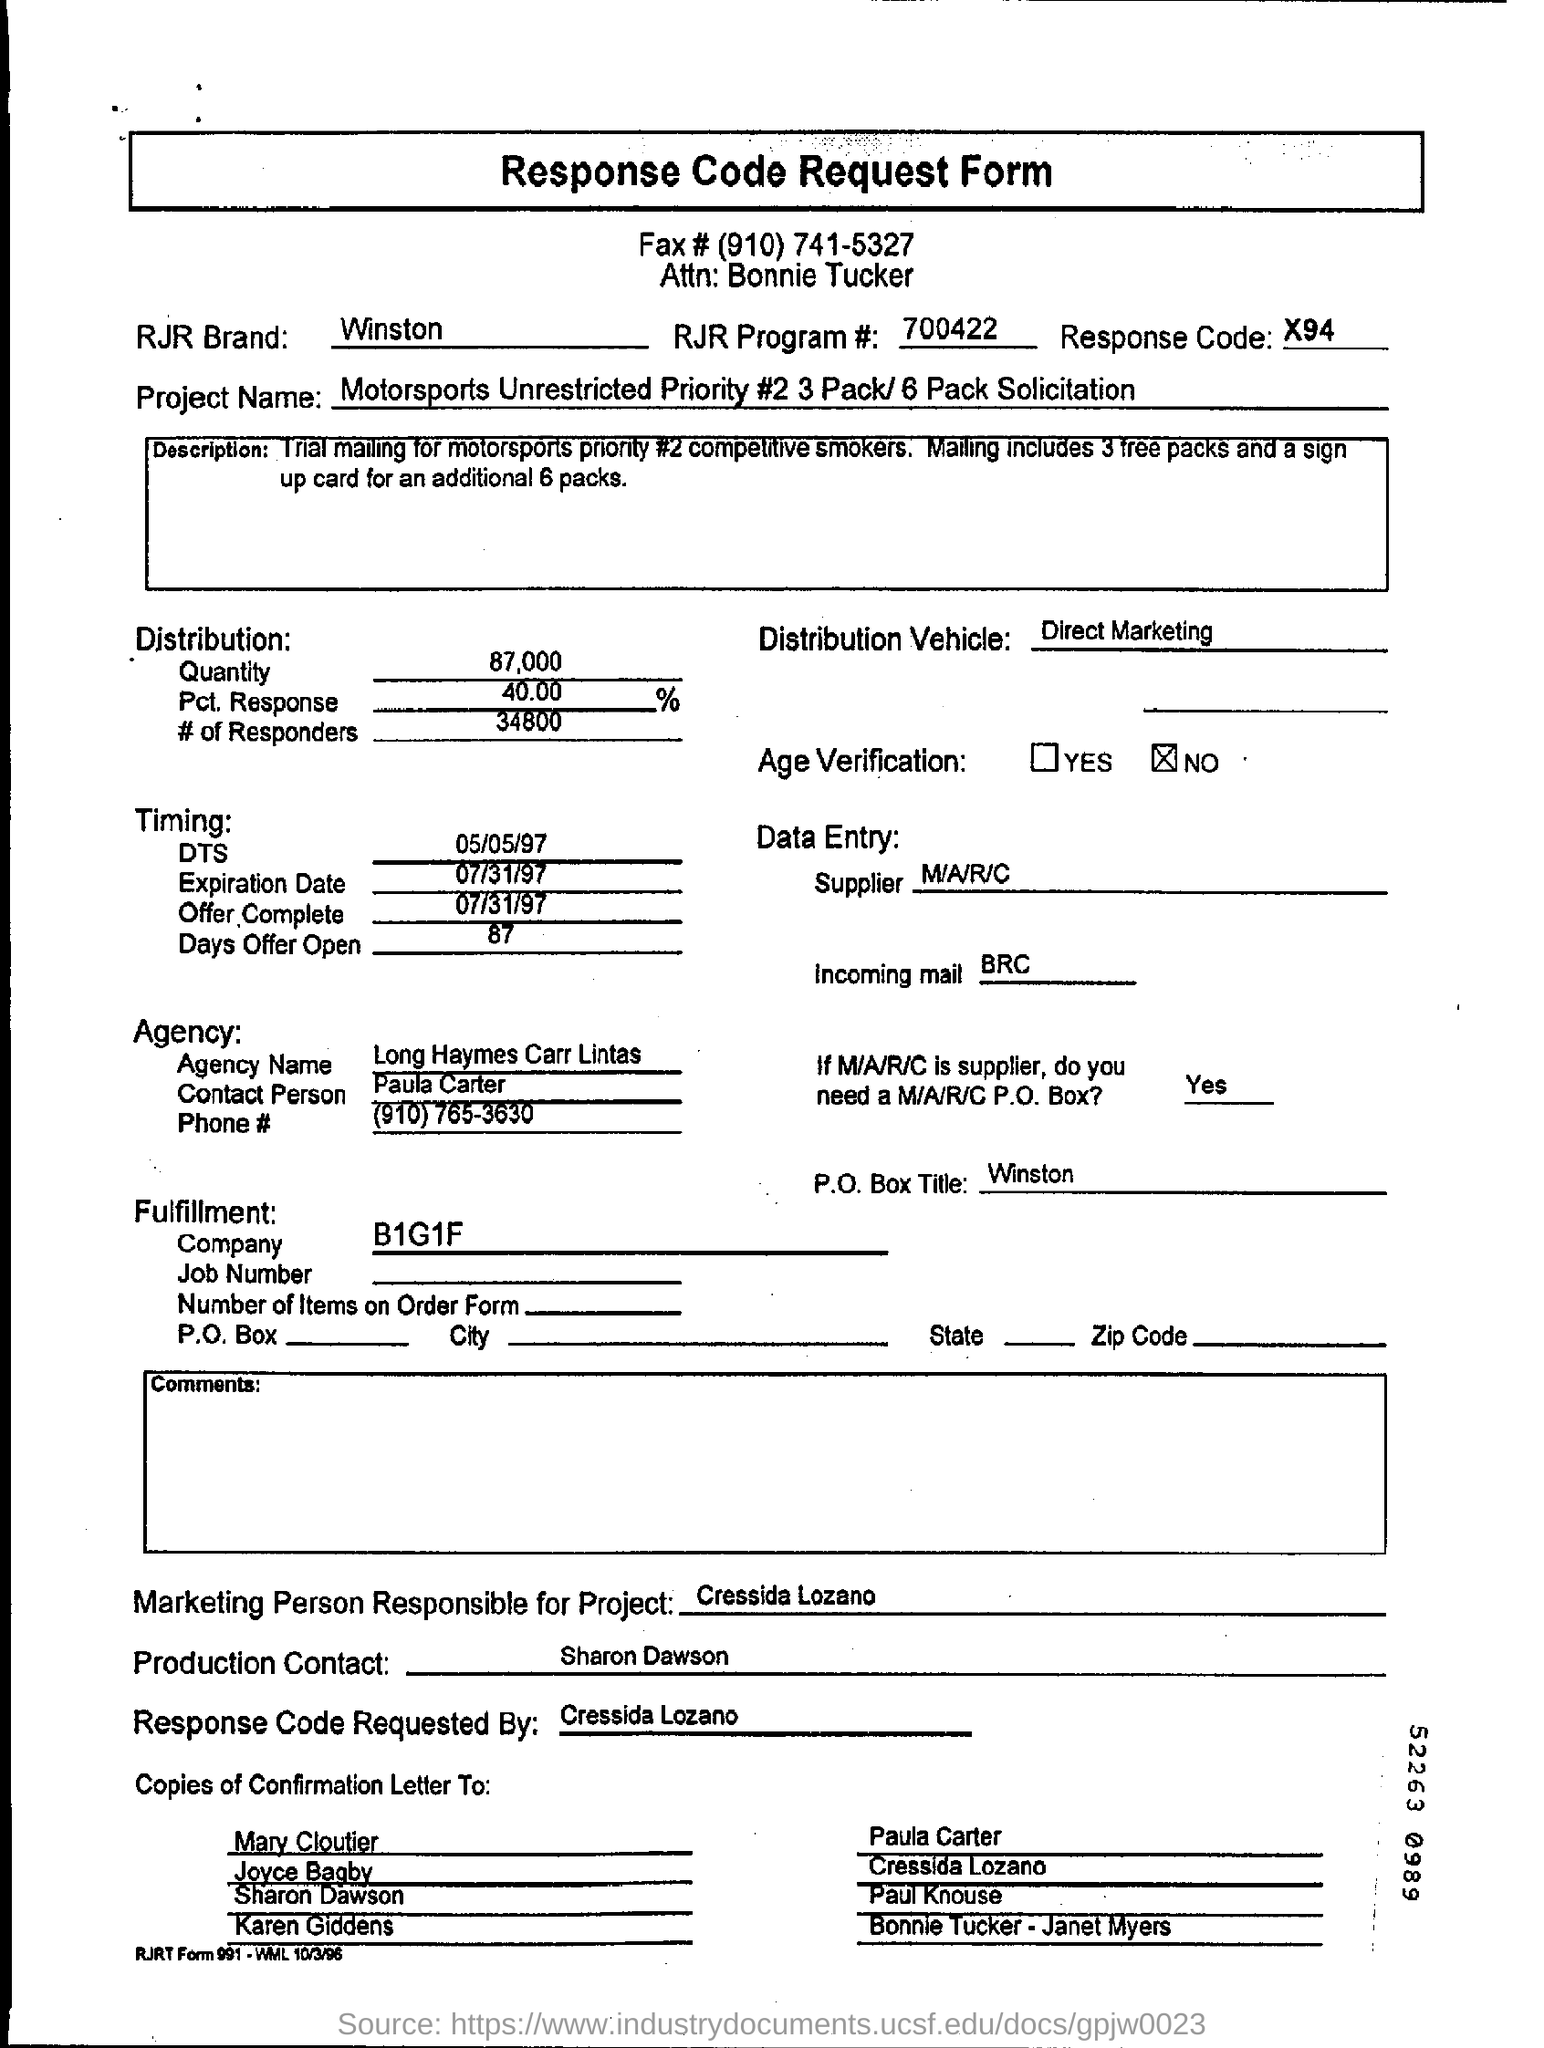What is the form about?
Keep it short and to the point. Response Code Request Form. What is the fax # given?
Your answer should be very brief. (910) 741-5327. What is the RJR brand mentioned?
Ensure brevity in your answer.  Winston. What is the RJR Program #?
Give a very brief answer. 700422. What is the Response Code?
Offer a terse response. X94. What is the Distribution Vehicle?
Offer a terse response. Direct Marketing. What is the agency name?
Keep it short and to the point. Long Haymes Carr Lintas. How much quantity is mentioned?
Give a very brief answer. 87,000. Who is the marketing person responsible for project?
Your answer should be compact. Cressida Lozano. 